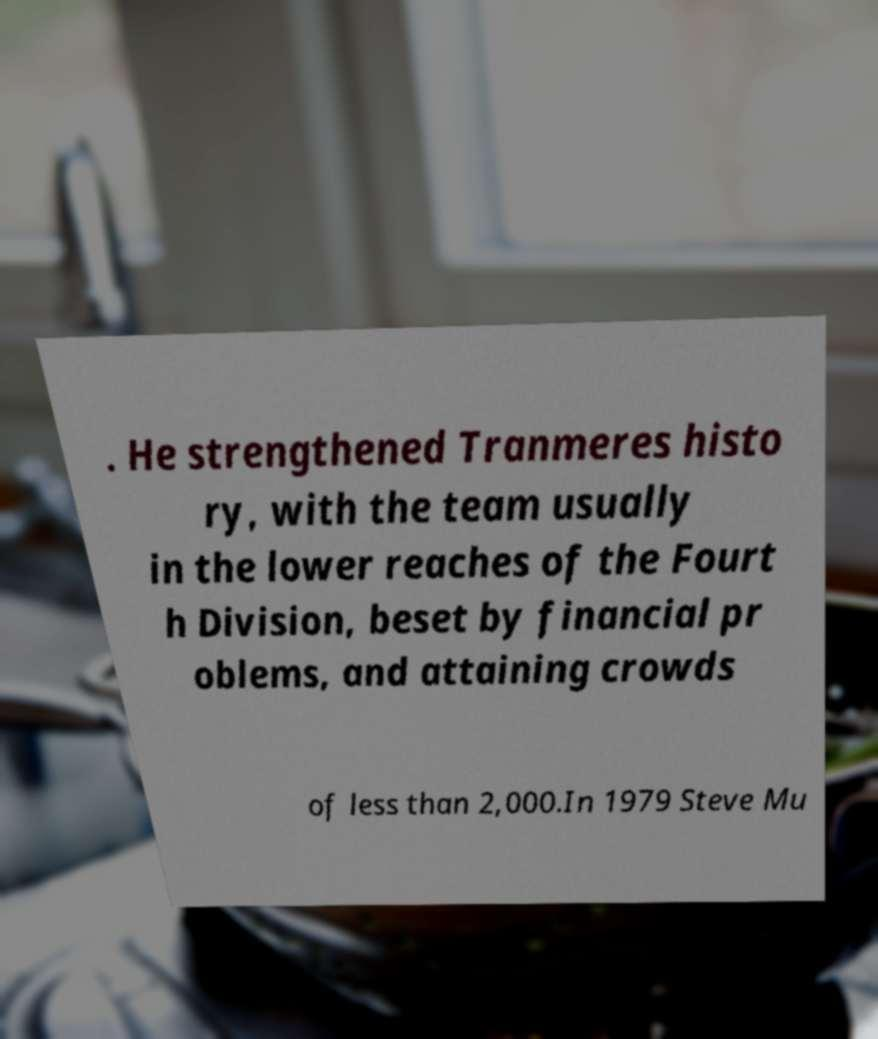Please identify and transcribe the text found in this image. . He strengthened Tranmeres histo ry, with the team usually in the lower reaches of the Fourt h Division, beset by financial pr oblems, and attaining crowds of less than 2,000.In 1979 Steve Mu 